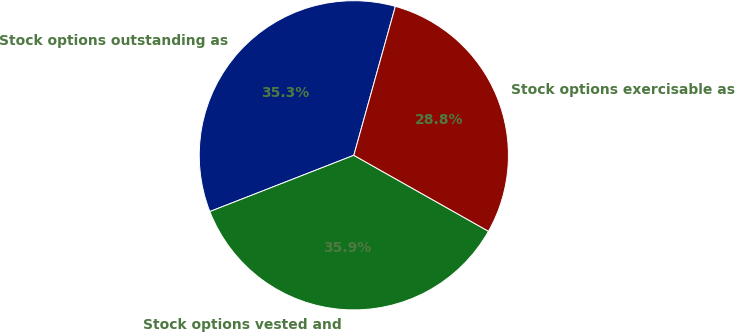<chart> <loc_0><loc_0><loc_500><loc_500><pie_chart><fcel>Stock options outstanding as<fcel>Stock options vested and<fcel>Stock options exercisable as<nl><fcel>35.26%<fcel>35.9%<fcel>28.85%<nl></chart> 